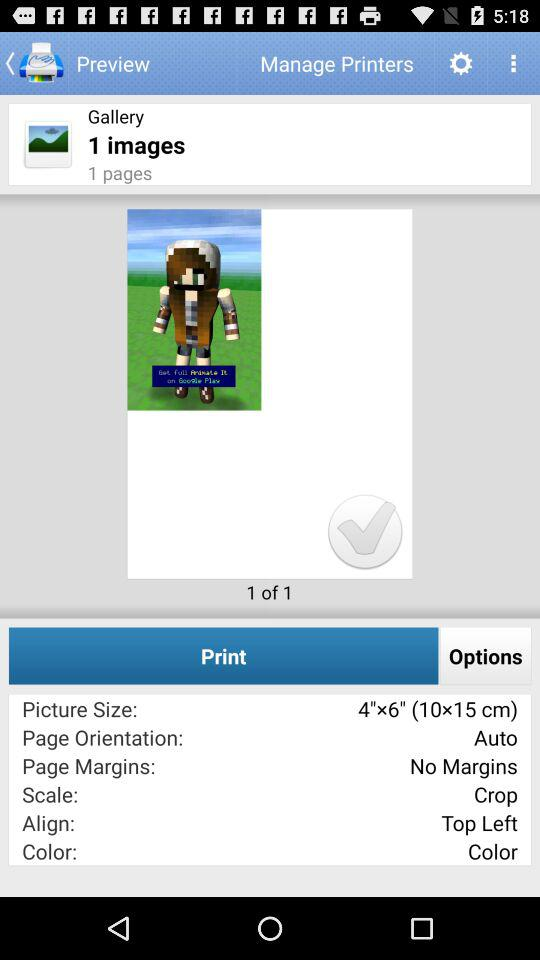What is the alignment? The alignment is top-left. 